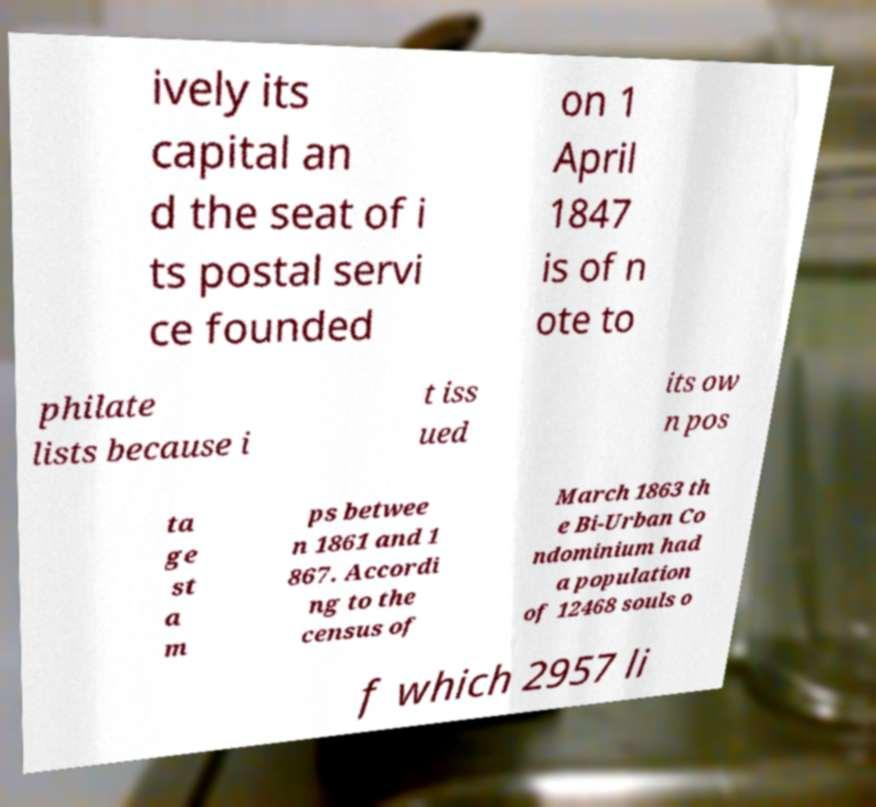For documentation purposes, I need the text within this image transcribed. Could you provide that? ively its capital an d the seat of i ts postal servi ce founded on 1 April 1847 is of n ote to philate lists because i t iss ued its ow n pos ta ge st a m ps betwee n 1861 and 1 867. Accordi ng to the census of March 1863 th e Bi-Urban Co ndominium had a population of 12468 souls o f which 2957 li 